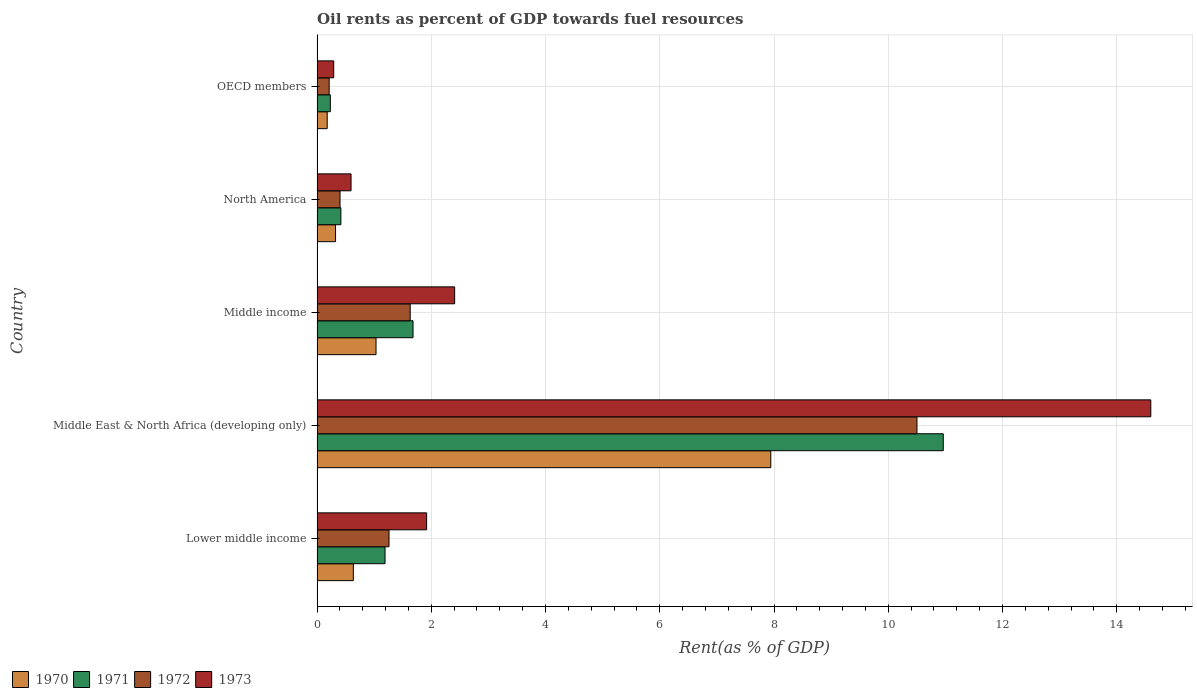How many different coloured bars are there?
Keep it short and to the point. 4. Are the number of bars per tick equal to the number of legend labels?
Provide a short and direct response. Yes. Are the number of bars on each tick of the Y-axis equal?
Ensure brevity in your answer.  Yes. What is the label of the 5th group of bars from the top?
Your answer should be compact. Lower middle income. What is the oil rent in 1972 in Middle East & North Africa (developing only)?
Make the answer very short. 10.5. Across all countries, what is the maximum oil rent in 1973?
Your response must be concise. 14.6. Across all countries, what is the minimum oil rent in 1972?
Give a very brief answer. 0.21. In which country was the oil rent in 1972 maximum?
Make the answer very short. Middle East & North Africa (developing only). In which country was the oil rent in 1970 minimum?
Offer a very short reply. OECD members. What is the total oil rent in 1973 in the graph?
Your response must be concise. 19.81. What is the difference between the oil rent in 1972 in Middle East & North Africa (developing only) and that in OECD members?
Your answer should be compact. 10.29. What is the difference between the oil rent in 1973 in OECD members and the oil rent in 1972 in Middle income?
Keep it short and to the point. -1.34. What is the average oil rent in 1970 per country?
Keep it short and to the point. 2.02. What is the difference between the oil rent in 1972 and oil rent in 1973 in Middle East & North Africa (developing only)?
Your response must be concise. -4.09. In how many countries, is the oil rent in 1971 greater than 12.8 %?
Offer a terse response. 0. What is the ratio of the oil rent in 1971 in Lower middle income to that in OECD members?
Ensure brevity in your answer.  5.12. Is the oil rent in 1970 in Lower middle income less than that in North America?
Ensure brevity in your answer.  No. Is the difference between the oil rent in 1972 in Lower middle income and OECD members greater than the difference between the oil rent in 1973 in Lower middle income and OECD members?
Your answer should be compact. No. What is the difference between the highest and the second highest oil rent in 1970?
Give a very brief answer. 6.91. What is the difference between the highest and the lowest oil rent in 1973?
Provide a succinct answer. 14.3. Is it the case that in every country, the sum of the oil rent in 1973 and oil rent in 1972 is greater than the sum of oil rent in 1971 and oil rent in 1970?
Give a very brief answer. No. What does the 3rd bar from the bottom in OECD members represents?
Provide a succinct answer. 1972. How many bars are there?
Ensure brevity in your answer.  20. Are all the bars in the graph horizontal?
Your answer should be very brief. Yes. What is the difference between two consecutive major ticks on the X-axis?
Your answer should be compact. 2. Are the values on the major ticks of X-axis written in scientific E-notation?
Keep it short and to the point. No. How many legend labels are there?
Give a very brief answer. 4. How are the legend labels stacked?
Make the answer very short. Horizontal. What is the title of the graph?
Your answer should be compact. Oil rents as percent of GDP towards fuel resources. What is the label or title of the X-axis?
Your answer should be compact. Rent(as % of GDP). What is the Rent(as % of GDP) in 1970 in Lower middle income?
Your response must be concise. 0.63. What is the Rent(as % of GDP) of 1971 in Lower middle income?
Ensure brevity in your answer.  1.19. What is the Rent(as % of GDP) of 1972 in Lower middle income?
Offer a terse response. 1.26. What is the Rent(as % of GDP) in 1973 in Lower middle income?
Keep it short and to the point. 1.92. What is the Rent(as % of GDP) in 1970 in Middle East & North Africa (developing only)?
Make the answer very short. 7.94. What is the Rent(as % of GDP) of 1971 in Middle East & North Africa (developing only)?
Ensure brevity in your answer.  10.96. What is the Rent(as % of GDP) of 1972 in Middle East & North Africa (developing only)?
Keep it short and to the point. 10.5. What is the Rent(as % of GDP) of 1973 in Middle East & North Africa (developing only)?
Your response must be concise. 14.6. What is the Rent(as % of GDP) in 1970 in Middle income?
Your answer should be compact. 1.03. What is the Rent(as % of GDP) in 1971 in Middle income?
Your answer should be compact. 1.68. What is the Rent(as % of GDP) in 1972 in Middle income?
Provide a succinct answer. 1.63. What is the Rent(as % of GDP) in 1973 in Middle income?
Ensure brevity in your answer.  2.41. What is the Rent(as % of GDP) in 1970 in North America?
Give a very brief answer. 0.32. What is the Rent(as % of GDP) of 1971 in North America?
Offer a very short reply. 0.42. What is the Rent(as % of GDP) in 1972 in North America?
Provide a succinct answer. 0.4. What is the Rent(as % of GDP) of 1973 in North America?
Offer a terse response. 0.6. What is the Rent(as % of GDP) of 1970 in OECD members?
Give a very brief answer. 0.18. What is the Rent(as % of GDP) of 1971 in OECD members?
Your response must be concise. 0.23. What is the Rent(as % of GDP) of 1972 in OECD members?
Your response must be concise. 0.21. What is the Rent(as % of GDP) of 1973 in OECD members?
Your answer should be compact. 0.29. Across all countries, what is the maximum Rent(as % of GDP) of 1970?
Your response must be concise. 7.94. Across all countries, what is the maximum Rent(as % of GDP) of 1971?
Provide a short and direct response. 10.96. Across all countries, what is the maximum Rent(as % of GDP) of 1972?
Provide a short and direct response. 10.5. Across all countries, what is the maximum Rent(as % of GDP) in 1973?
Offer a terse response. 14.6. Across all countries, what is the minimum Rent(as % of GDP) of 1970?
Make the answer very short. 0.18. Across all countries, what is the minimum Rent(as % of GDP) in 1971?
Make the answer very short. 0.23. Across all countries, what is the minimum Rent(as % of GDP) of 1972?
Ensure brevity in your answer.  0.21. Across all countries, what is the minimum Rent(as % of GDP) in 1973?
Your answer should be compact. 0.29. What is the total Rent(as % of GDP) of 1970 in the graph?
Offer a terse response. 10.11. What is the total Rent(as % of GDP) of 1971 in the graph?
Give a very brief answer. 14.48. What is the total Rent(as % of GDP) of 1972 in the graph?
Your answer should be very brief. 14.01. What is the total Rent(as % of GDP) in 1973 in the graph?
Provide a succinct answer. 19.81. What is the difference between the Rent(as % of GDP) in 1970 in Lower middle income and that in Middle East & North Africa (developing only)?
Keep it short and to the point. -7.31. What is the difference between the Rent(as % of GDP) of 1971 in Lower middle income and that in Middle East & North Africa (developing only)?
Offer a terse response. -9.77. What is the difference between the Rent(as % of GDP) in 1972 in Lower middle income and that in Middle East & North Africa (developing only)?
Offer a very short reply. -9.24. What is the difference between the Rent(as % of GDP) in 1973 in Lower middle income and that in Middle East & North Africa (developing only)?
Offer a very short reply. -12.68. What is the difference between the Rent(as % of GDP) of 1970 in Lower middle income and that in Middle income?
Provide a succinct answer. -0.4. What is the difference between the Rent(as % of GDP) in 1971 in Lower middle income and that in Middle income?
Your answer should be compact. -0.49. What is the difference between the Rent(as % of GDP) in 1972 in Lower middle income and that in Middle income?
Your answer should be very brief. -0.37. What is the difference between the Rent(as % of GDP) of 1973 in Lower middle income and that in Middle income?
Provide a succinct answer. -0.49. What is the difference between the Rent(as % of GDP) of 1970 in Lower middle income and that in North America?
Offer a terse response. 0.31. What is the difference between the Rent(as % of GDP) in 1971 in Lower middle income and that in North America?
Give a very brief answer. 0.77. What is the difference between the Rent(as % of GDP) in 1972 in Lower middle income and that in North America?
Provide a short and direct response. 0.86. What is the difference between the Rent(as % of GDP) of 1973 in Lower middle income and that in North America?
Provide a succinct answer. 1.32. What is the difference between the Rent(as % of GDP) in 1970 in Lower middle income and that in OECD members?
Your answer should be very brief. 0.46. What is the difference between the Rent(as % of GDP) in 1971 in Lower middle income and that in OECD members?
Your response must be concise. 0.96. What is the difference between the Rent(as % of GDP) of 1972 in Lower middle income and that in OECD members?
Provide a short and direct response. 1.05. What is the difference between the Rent(as % of GDP) in 1973 in Lower middle income and that in OECD members?
Give a very brief answer. 1.63. What is the difference between the Rent(as % of GDP) in 1970 in Middle East & North Africa (developing only) and that in Middle income?
Keep it short and to the point. 6.91. What is the difference between the Rent(as % of GDP) of 1971 in Middle East & North Africa (developing only) and that in Middle income?
Give a very brief answer. 9.28. What is the difference between the Rent(as % of GDP) in 1972 in Middle East & North Africa (developing only) and that in Middle income?
Ensure brevity in your answer.  8.87. What is the difference between the Rent(as % of GDP) of 1973 in Middle East & North Africa (developing only) and that in Middle income?
Provide a short and direct response. 12.19. What is the difference between the Rent(as % of GDP) in 1970 in Middle East & North Africa (developing only) and that in North America?
Your answer should be very brief. 7.62. What is the difference between the Rent(as % of GDP) in 1971 in Middle East & North Africa (developing only) and that in North America?
Give a very brief answer. 10.55. What is the difference between the Rent(as % of GDP) of 1972 in Middle East & North Africa (developing only) and that in North America?
Keep it short and to the point. 10.1. What is the difference between the Rent(as % of GDP) of 1973 in Middle East & North Africa (developing only) and that in North America?
Your answer should be compact. 14. What is the difference between the Rent(as % of GDP) of 1970 in Middle East & North Africa (developing only) and that in OECD members?
Your response must be concise. 7.77. What is the difference between the Rent(as % of GDP) of 1971 in Middle East & North Africa (developing only) and that in OECD members?
Provide a short and direct response. 10.73. What is the difference between the Rent(as % of GDP) in 1972 in Middle East & North Africa (developing only) and that in OECD members?
Provide a short and direct response. 10.29. What is the difference between the Rent(as % of GDP) in 1973 in Middle East & North Africa (developing only) and that in OECD members?
Offer a terse response. 14.3. What is the difference between the Rent(as % of GDP) in 1970 in Middle income and that in North America?
Give a very brief answer. 0.71. What is the difference between the Rent(as % of GDP) of 1971 in Middle income and that in North America?
Offer a terse response. 1.26. What is the difference between the Rent(as % of GDP) of 1972 in Middle income and that in North America?
Provide a succinct answer. 1.23. What is the difference between the Rent(as % of GDP) in 1973 in Middle income and that in North America?
Your response must be concise. 1.81. What is the difference between the Rent(as % of GDP) of 1970 in Middle income and that in OECD members?
Your answer should be compact. 0.85. What is the difference between the Rent(as % of GDP) in 1971 in Middle income and that in OECD members?
Keep it short and to the point. 1.45. What is the difference between the Rent(as % of GDP) in 1972 in Middle income and that in OECD members?
Keep it short and to the point. 1.42. What is the difference between the Rent(as % of GDP) of 1973 in Middle income and that in OECD members?
Keep it short and to the point. 2.12. What is the difference between the Rent(as % of GDP) in 1970 in North America and that in OECD members?
Offer a terse response. 0.15. What is the difference between the Rent(as % of GDP) in 1971 in North America and that in OECD members?
Give a very brief answer. 0.18. What is the difference between the Rent(as % of GDP) of 1972 in North America and that in OECD members?
Ensure brevity in your answer.  0.19. What is the difference between the Rent(as % of GDP) in 1973 in North America and that in OECD members?
Your response must be concise. 0.3. What is the difference between the Rent(as % of GDP) of 1970 in Lower middle income and the Rent(as % of GDP) of 1971 in Middle East & North Africa (developing only)?
Your answer should be very brief. -10.33. What is the difference between the Rent(as % of GDP) of 1970 in Lower middle income and the Rent(as % of GDP) of 1972 in Middle East & North Africa (developing only)?
Provide a short and direct response. -9.87. What is the difference between the Rent(as % of GDP) of 1970 in Lower middle income and the Rent(as % of GDP) of 1973 in Middle East & North Africa (developing only)?
Offer a very short reply. -13.96. What is the difference between the Rent(as % of GDP) of 1971 in Lower middle income and the Rent(as % of GDP) of 1972 in Middle East & North Africa (developing only)?
Make the answer very short. -9.31. What is the difference between the Rent(as % of GDP) of 1971 in Lower middle income and the Rent(as % of GDP) of 1973 in Middle East & North Africa (developing only)?
Provide a short and direct response. -13.41. What is the difference between the Rent(as % of GDP) of 1972 in Lower middle income and the Rent(as % of GDP) of 1973 in Middle East & North Africa (developing only)?
Your answer should be very brief. -13.34. What is the difference between the Rent(as % of GDP) of 1970 in Lower middle income and the Rent(as % of GDP) of 1971 in Middle income?
Make the answer very short. -1.05. What is the difference between the Rent(as % of GDP) in 1970 in Lower middle income and the Rent(as % of GDP) in 1972 in Middle income?
Offer a very short reply. -1. What is the difference between the Rent(as % of GDP) in 1970 in Lower middle income and the Rent(as % of GDP) in 1973 in Middle income?
Offer a very short reply. -1.77. What is the difference between the Rent(as % of GDP) in 1971 in Lower middle income and the Rent(as % of GDP) in 1972 in Middle income?
Offer a terse response. -0.44. What is the difference between the Rent(as % of GDP) in 1971 in Lower middle income and the Rent(as % of GDP) in 1973 in Middle income?
Ensure brevity in your answer.  -1.22. What is the difference between the Rent(as % of GDP) of 1972 in Lower middle income and the Rent(as % of GDP) of 1973 in Middle income?
Ensure brevity in your answer.  -1.15. What is the difference between the Rent(as % of GDP) in 1970 in Lower middle income and the Rent(as % of GDP) in 1971 in North America?
Your answer should be compact. 0.22. What is the difference between the Rent(as % of GDP) of 1970 in Lower middle income and the Rent(as % of GDP) of 1972 in North America?
Ensure brevity in your answer.  0.23. What is the difference between the Rent(as % of GDP) in 1970 in Lower middle income and the Rent(as % of GDP) in 1973 in North America?
Your answer should be very brief. 0.04. What is the difference between the Rent(as % of GDP) in 1971 in Lower middle income and the Rent(as % of GDP) in 1972 in North America?
Ensure brevity in your answer.  0.79. What is the difference between the Rent(as % of GDP) in 1971 in Lower middle income and the Rent(as % of GDP) in 1973 in North America?
Ensure brevity in your answer.  0.6. What is the difference between the Rent(as % of GDP) of 1972 in Lower middle income and the Rent(as % of GDP) of 1973 in North America?
Keep it short and to the point. 0.66. What is the difference between the Rent(as % of GDP) of 1970 in Lower middle income and the Rent(as % of GDP) of 1971 in OECD members?
Offer a terse response. 0.4. What is the difference between the Rent(as % of GDP) of 1970 in Lower middle income and the Rent(as % of GDP) of 1972 in OECD members?
Your answer should be compact. 0.42. What is the difference between the Rent(as % of GDP) in 1970 in Lower middle income and the Rent(as % of GDP) in 1973 in OECD members?
Offer a very short reply. 0.34. What is the difference between the Rent(as % of GDP) in 1971 in Lower middle income and the Rent(as % of GDP) in 1972 in OECD members?
Provide a short and direct response. 0.98. What is the difference between the Rent(as % of GDP) in 1971 in Lower middle income and the Rent(as % of GDP) in 1973 in OECD members?
Provide a short and direct response. 0.9. What is the difference between the Rent(as % of GDP) in 1972 in Lower middle income and the Rent(as % of GDP) in 1973 in OECD members?
Your answer should be compact. 0.97. What is the difference between the Rent(as % of GDP) in 1970 in Middle East & North Africa (developing only) and the Rent(as % of GDP) in 1971 in Middle income?
Your answer should be compact. 6.26. What is the difference between the Rent(as % of GDP) of 1970 in Middle East & North Africa (developing only) and the Rent(as % of GDP) of 1972 in Middle income?
Ensure brevity in your answer.  6.31. What is the difference between the Rent(as % of GDP) in 1970 in Middle East & North Africa (developing only) and the Rent(as % of GDP) in 1973 in Middle income?
Give a very brief answer. 5.53. What is the difference between the Rent(as % of GDP) of 1971 in Middle East & North Africa (developing only) and the Rent(as % of GDP) of 1972 in Middle income?
Make the answer very short. 9.33. What is the difference between the Rent(as % of GDP) in 1971 in Middle East & North Africa (developing only) and the Rent(as % of GDP) in 1973 in Middle income?
Give a very brief answer. 8.55. What is the difference between the Rent(as % of GDP) of 1972 in Middle East & North Africa (developing only) and the Rent(as % of GDP) of 1973 in Middle income?
Ensure brevity in your answer.  8.09. What is the difference between the Rent(as % of GDP) in 1970 in Middle East & North Africa (developing only) and the Rent(as % of GDP) in 1971 in North America?
Provide a short and direct response. 7.53. What is the difference between the Rent(as % of GDP) in 1970 in Middle East & North Africa (developing only) and the Rent(as % of GDP) in 1972 in North America?
Provide a succinct answer. 7.54. What is the difference between the Rent(as % of GDP) in 1970 in Middle East & North Africa (developing only) and the Rent(as % of GDP) in 1973 in North America?
Give a very brief answer. 7.35. What is the difference between the Rent(as % of GDP) in 1971 in Middle East & North Africa (developing only) and the Rent(as % of GDP) in 1972 in North America?
Give a very brief answer. 10.56. What is the difference between the Rent(as % of GDP) of 1971 in Middle East & North Africa (developing only) and the Rent(as % of GDP) of 1973 in North America?
Your answer should be compact. 10.37. What is the difference between the Rent(as % of GDP) in 1972 in Middle East & North Africa (developing only) and the Rent(as % of GDP) in 1973 in North America?
Provide a short and direct response. 9.91. What is the difference between the Rent(as % of GDP) of 1970 in Middle East & North Africa (developing only) and the Rent(as % of GDP) of 1971 in OECD members?
Make the answer very short. 7.71. What is the difference between the Rent(as % of GDP) of 1970 in Middle East & North Africa (developing only) and the Rent(as % of GDP) of 1972 in OECD members?
Ensure brevity in your answer.  7.73. What is the difference between the Rent(as % of GDP) in 1970 in Middle East & North Africa (developing only) and the Rent(as % of GDP) in 1973 in OECD members?
Offer a terse response. 7.65. What is the difference between the Rent(as % of GDP) in 1971 in Middle East & North Africa (developing only) and the Rent(as % of GDP) in 1972 in OECD members?
Provide a succinct answer. 10.75. What is the difference between the Rent(as % of GDP) in 1971 in Middle East & North Africa (developing only) and the Rent(as % of GDP) in 1973 in OECD members?
Your response must be concise. 10.67. What is the difference between the Rent(as % of GDP) in 1972 in Middle East & North Africa (developing only) and the Rent(as % of GDP) in 1973 in OECD members?
Your answer should be compact. 10.21. What is the difference between the Rent(as % of GDP) in 1970 in Middle income and the Rent(as % of GDP) in 1971 in North America?
Provide a succinct answer. 0.61. What is the difference between the Rent(as % of GDP) in 1970 in Middle income and the Rent(as % of GDP) in 1972 in North America?
Keep it short and to the point. 0.63. What is the difference between the Rent(as % of GDP) of 1970 in Middle income and the Rent(as % of GDP) of 1973 in North America?
Give a very brief answer. 0.44. What is the difference between the Rent(as % of GDP) in 1971 in Middle income and the Rent(as % of GDP) in 1972 in North America?
Make the answer very short. 1.28. What is the difference between the Rent(as % of GDP) of 1971 in Middle income and the Rent(as % of GDP) of 1973 in North America?
Keep it short and to the point. 1.09. What is the difference between the Rent(as % of GDP) in 1972 in Middle income and the Rent(as % of GDP) in 1973 in North America?
Offer a terse response. 1.04. What is the difference between the Rent(as % of GDP) in 1970 in Middle income and the Rent(as % of GDP) in 1971 in OECD members?
Offer a very short reply. 0.8. What is the difference between the Rent(as % of GDP) in 1970 in Middle income and the Rent(as % of GDP) in 1972 in OECD members?
Keep it short and to the point. 0.82. What is the difference between the Rent(as % of GDP) in 1970 in Middle income and the Rent(as % of GDP) in 1973 in OECD members?
Give a very brief answer. 0.74. What is the difference between the Rent(as % of GDP) of 1971 in Middle income and the Rent(as % of GDP) of 1972 in OECD members?
Offer a very short reply. 1.47. What is the difference between the Rent(as % of GDP) of 1971 in Middle income and the Rent(as % of GDP) of 1973 in OECD members?
Offer a terse response. 1.39. What is the difference between the Rent(as % of GDP) of 1972 in Middle income and the Rent(as % of GDP) of 1973 in OECD members?
Your answer should be very brief. 1.34. What is the difference between the Rent(as % of GDP) of 1970 in North America and the Rent(as % of GDP) of 1971 in OECD members?
Keep it short and to the point. 0.09. What is the difference between the Rent(as % of GDP) of 1970 in North America and the Rent(as % of GDP) of 1972 in OECD members?
Offer a very short reply. 0.11. What is the difference between the Rent(as % of GDP) of 1970 in North America and the Rent(as % of GDP) of 1973 in OECD members?
Offer a very short reply. 0.03. What is the difference between the Rent(as % of GDP) of 1971 in North America and the Rent(as % of GDP) of 1972 in OECD members?
Offer a very short reply. 0.21. What is the difference between the Rent(as % of GDP) in 1971 in North America and the Rent(as % of GDP) in 1973 in OECD members?
Provide a short and direct response. 0.13. What is the difference between the Rent(as % of GDP) of 1972 in North America and the Rent(as % of GDP) of 1973 in OECD members?
Offer a terse response. 0.11. What is the average Rent(as % of GDP) in 1970 per country?
Make the answer very short. 2.02. What is the average Rent(as % of GDP) of 1971 per country?
Offer a very short reply. 2.9. What is the average Rent(as % of GDP) in 1972 per country?
Offer a very short reply. 2.8. What is the average Rent(as % of GDP) of 1973 per country?
Ensure brevity in your answer.  3.96. What is the difference between the Rent(as % of GDP) of 1970 and Rent(as % of GDP) of 1971 in Lower middle income?
Your response must be concise. -0.56. What is the difference between the Rent(as % of GDP) in 1970 and Rent(as % of GDP) in 1972 in Lower middle income?
Provide a succinct answer. -0.62. What is the difference between the Rent(as % of GDP) in 1970 and Rent(as % of GDP) in 1973 in Lower middle income?
Your response must be concise. -1.28. What is the difference between the Rent(as % of GDP) of 1971 and Rent(as % of GDP) of 1972 in Lower middle income?
Make the answer very short. -0.07. What is the difference between the Rent(as % of GDP) in 1971 and Rent(as % of GDP) in 1973 in Lower middle income?
Keep it short and to the point. -0.73. What is the difference between the Rent(as % of GDP) in 1972 and Rent(as % of GDP) in 1973 in Lower middle income?
Offer a terse response. -0.66. What is the difference between the Rent(as % of GDP) of 1970 and Rent(as % of GDP) of 1971 in Middle East & North Africa (developing only)?
Keep it short and to the point. -3.02. What is the difference between the Rent(as % of GDP) in 1970 and Rent(as % of GDP) in 1972 in Middle East & North Africa (developing only)?
Ensure brevity in your answer.  -2.56. What is the difference between the Rent(as % of GDP) of 1970 and Rent(as % of GDP) of 1973 in Middle East & North Africa (developing only)?
Offer a very short reply. -6.65. What is the difference between the Rent(as % of GDP) of 1971 and Rent(as % of GDP) of 1972 in Middle East & North Africa (developing only)?
Provide a short and direct response. 0.46. What is the difference between the Rent(as % of GDP) in 1971 and Rent(as % of GDP) in 1973 in Middle East & North Africa (developing only)?
Offer a very short reply. -3.63. What is the difference between the Rent(as % of GDP) in 1972 and Rent(as % of GDP) in 1973 in Middle East & North Africa (developing only)?
Ensure brevity in your answer.  -4.09. What is the difference between the Rent(as % of GDP) in 1970 and Rent(as % of GDP) in 1971 in Middle income?
Give a very brief answer. -0.65. What is the difference between the Rent(as % of GDP) of 1970 and Rent(as % of GDP) of 1972 in Middle income?
Offer a terse response. -0.6. What is the difference between the Rent(as % of GDP) of 1970 and Rent(as % of GDP) of 1973 in Middle income?
Your answer should be compact. -1.38. What is the difference between the Rent(as % of GDP) of 1971 and Rent(as % of GDP) of 1972 in Middle income?
Keep it short and to the point. 0.05. What is the difference between the Rent(as % of GDP) of 1971 and Rent(as % of GDP) of 1973 in Middle income?
Offer a terse response. -0.73. What is the difference between the Rent(as % of GDP) in 1972 and Rent(as % of GDP) in 1973 in Middle income?
Offer a very short reply. -0.78. What is the difference between the Rent(as % of GDP) in 1970 and Rent(as % of GDP) in 1971 in North America?
Offer a terse response. -0.09. What is the difference between the Rent(as % of GDP) of 1970 and Rent(as % of GDP) of 1972 in North America?
Your answer should be compact. -0.08. What is the difference between the Rent(as % of GDP) in 1970 and Rent(as % of GDP) in 1973 in North America?
Give a very brief answer. -0.27. What is the difference between the Rent(as % of GDP) of 1971 and Rent(as % of GDP) of 1972 in North America?
Your answer should be compact. 0.02. What is the difference between the Rent(as % of GDP) in 1971 and Rent(as % of GDP) in 1973 in North America?
Make the answer very short. -0.18. What is the difference between the Rent(as % of GDP) in 1972 and Rent(as % of GDP) in 1973 in North America?
Keep it short and to the point. -0.19. What is the difference between the Rent(as % of GDP) in 1970 and Rent(as % of GDP) in 1971 in OECD members?
Your answer should be very brief. -0.05. What is the difference between the Rent(as % of GDP) in 1970 and Rent(as % of GDP) in 1972 in OECD members?
Ensure brevity in your answer.  -0.03. What is the difference between the Rent(as % of GDP) of 1970 and Rent(as % of GDP) of 1973 in OECD members?
Provide a short and direct response. -0.11. What is the difference between the Rent(as % of GDP) in 1971 and Rent(as % of GDP) in 1972 in OECD members?
Offer a very short reply. 0.02. What is the difference between the Rent(as % of GDP) in 1971 and Rent(as % of GDP) in 1973 in OECD members?
Your answer should be very brief. -0.06. What is the difference between the Rent(as % of GDP) of 1972 and Rent(as % of GDP) of 1973 in OECD members?
Offer a very short reply. -0.08. What is the ratio of the Rent(as % of GDP) in 1970 in Lower middle income to that in Middle East & North Africa (developing only)?
Keep it short and to the point. 0.08. What is the ratio of the Rent(as % of GDP) in 1971 in Lower middle income to that in Middle East & North Africa (developing only)?
Your response must be concise. 0.11. What is the ratio of the Rent(as % of GDP) of 1972 in Lower middle income to that in Middle East & North Africa (developing only)?
Give a very brief answer. 0.12. What is the ratio of the Rent(as % of GDP) of 1973 in Lower middle income to that in Middle East & North Africa (developing only)?
Your response must be concise. 0.13. What is the ratio of the Rent(as % of GDP) in 1970 in Lower middle income to that in Middle income?
Keep it short and to the point. 0.61. What is the ratio of the Rent(as % of GDP) in 1971 in Lower middle income to that in Middle income?
Keep it short and to the point. 0.71. What is the ratio of the Rent(as % of GDP) of 1972 in Lower middle income to that in Middle income?
Ensure brevity in your answer.  0.77. What is the ratio of the Rent(as % of GDP) of 1973 in Lower middle income to that in Middle income?
Your answer should be very brief. 0.8. What is the ratio of the Rent(as % of GDP) in 1970 in Lower middle income to that in North America?
Your answer should be compact. 1.96. What is the ratio of the Rent(as % of GDP) in 1971 in Lower middle income to that in North America?
Provide a short and direct response. 2.85. What is the ratio of the Rent(as % of GDP) of 1972 in Lower middle income to that in North America?
Give a very brief answer. 3.13. What is the ratio of the Rent(as % of GDP) of 1973 in Lower middle income to that in North America?
Give a very brief answer. 3.22. What is the ratio of the Rent(as % of GDP) in 1970 in Lower middle income to that in OECD members?
Your response must be concise. 3.57. What is the ratio of the Rent(as % of GDP) in 1971 in Lower middle income to that in OECD members?
Your response must be concise. 5.12. What is the ratio of the Rent(as % of GDP) in 1972 in Lower middle income to that in OECD members?
Give a very brief answer. 5.94. What is the ratio of the Rent(as % of GDP) of 1973 in Lower middle income to that in OECD members?
Your answer should be very brief. 6.58. What is the ratio of the Rent(as % of GDP) in 1970 in Middle East & North Africa (developing only) to that in Middle income?
Give a very brief answer. 7.69. What is the ratio of the Rent(as % of GDP) in 1971 in Middle East & North Africa (developing only) to that in Middle income?
Ensure brevity in your answer.  6.52. What is the ratio of the Rent(as % of GDP) of 1972 in Middle East & North Africa (developing only) to that in Middle income?
Keep it short and to the point. 6.44. What is the ratio of the Rent(as % of GDP) of 1973 in Middle East & North Africa (developing only) to that in Middle income?
Keep it short and to the point. 6.06. What is the ratio of the Rent(as % of GDP) in 1970 in Middle East & North Africa (developing only) to that in North America?
Provide a short and direct response. 24.54. What is the ratio of the Rent(as % of GDP) of 1971 in Middle East & North Africa (developing only) to that in North America?
Offer a terse response. 26.26. What is the ratio of the Rent(as % of GDP) of 1972 in Middle East & North Africa (developing only) to that in North America?
Provide a short and direct response. 26.11. What is the ratio of the Rent(as % of GDP) of 1973 in Middle East & North Africa (developing only) to that in North America?
Your answer should be compact. 24.53. What is the ratio of the Rent(as % of GDP) of 1970 in Middle East & North Africa (developing only) to that in OECD members?
Offer a terse response. 44.68. What is the ratio of the Rent(as % of GDP) of 1971 in Middle East & North Africa (developing only) to that in OECD members?
Ensure brevity in your answer.  47.15. What is the ratio of the Rent(as % of GDP) of 1972 in Middle East & North Africa (developing only) to that in OECD members?
Your answer should be very brief. 49.49. What is the ratio of the Rent(as % of GDP) in 1973 in Middle East & North Africa (developing only) to that in OECD members?
Your answer should be very brief. 50.04. What is the ratio of the Rent(as % of GDP) in 1970 in Middle income to that in North America?
Keep it short and to the point. 3.19. What is the ratio of the Rent(as % of GDP) in 1971 in Middle income to that in North America?
Provide a short and direct response. 4.03. What is the ratio of the Rent(as % of GDP) of 1972 in Middle income to that in North America?
Offer a terse response. 4.05. What is the ratio of the Rent(as % of GDP) of 1973 in Middle income to that in North America?
Your response must be concise. 4.05. What is the ratio of the Rent(as % of GDP) of 1970 in Middle income to that in OECD members?
Offer a terse response. 5.81. What is the ratio of the Rent(as % of GDP) of 1971 in Middle income to that in OECD members?
Make the answer very short. 7.23. What is the ratio of the Rent(as % of GDP) of 1972 in Middle income to that in OECD members?
Your answer should be very brief. 7.68. What is the ratio of the Rent(as % of GDP) in 1973 in Middle income to that in OECD members?
Your answer should be very brief. 8.26. What is the ratio of the Rent(as % of GDP) of 1970 in North America to that in OECD members?
Ensure brevity in your answer.  1.82. What is the ratio of the Rent(as % of GDP) of 1971 in North America to that in OECD members?
Offer a terse response. 1.8. What is the ratio of the Rent(as % of GDP) of 1972 in North America to that in OECD members?
Make the answer very short. 1.9. What is the ratio of the Rent(as % of GDP) of 1973 in North America to that in OECD members?
Offer a terse response. 2.04. What is the difference between the highest and the second highest Rent(as % of GDP) in 1970?
Your answer should be compact. 6.91. What is the difference between the highest and the second highest Rent(as % of GDP) in 1971?
Give a very brief answer. 9.28. What is the difference between the highest and the second highest Rent(as % of GDP) of 1972?
Provide a short and direct response. 8.87. What is the difference between the highest and the second highest Rent(as % of GDP) of 1973?
Your response must be concise. 12.19. What is the difference between the highest and the lowest Rent(as % of GDP) in 1970?
Your answer should be compact. 7.77. What is the difference between the highest and the lowest Rent(as % of GDP) of 1971?
Your answer should be compact. 10.73. What is the difference between the highest and the lowest Rent(as % of GDP) in 1972?
Provide a short and direct response. 10.29. What is the difference between the highest and the lowest Rent(as % of GDP) of 1973?
Ensure brevity in your answer.  14.3. 